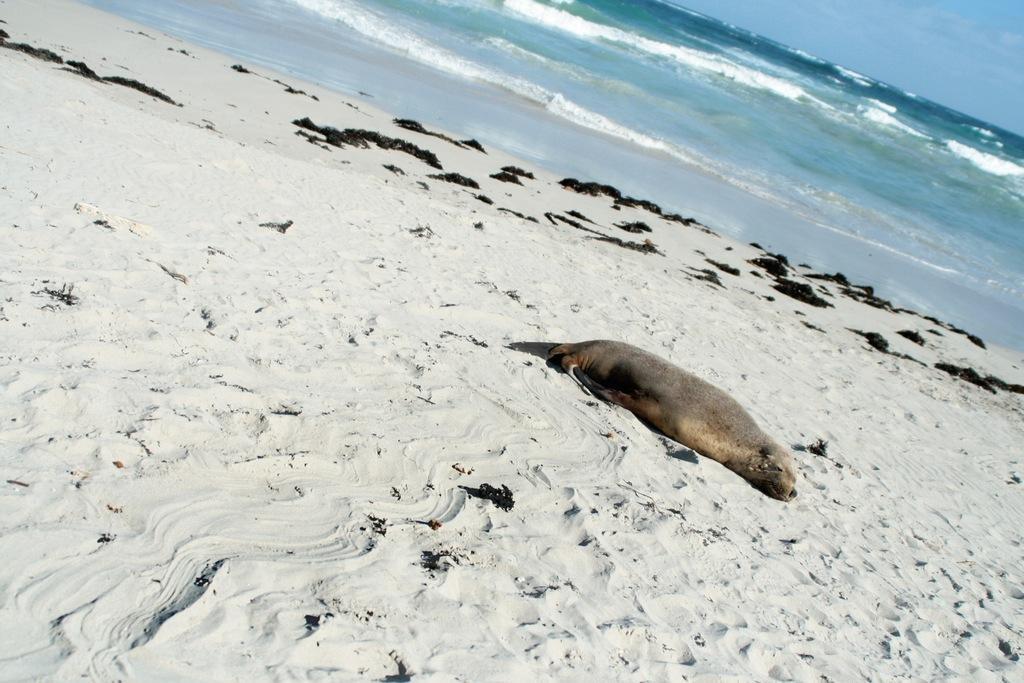How would you summarize this image in a sentence or two? In this image we can see an animal lying on the sand, we can see the sea and the sky with clouds. 